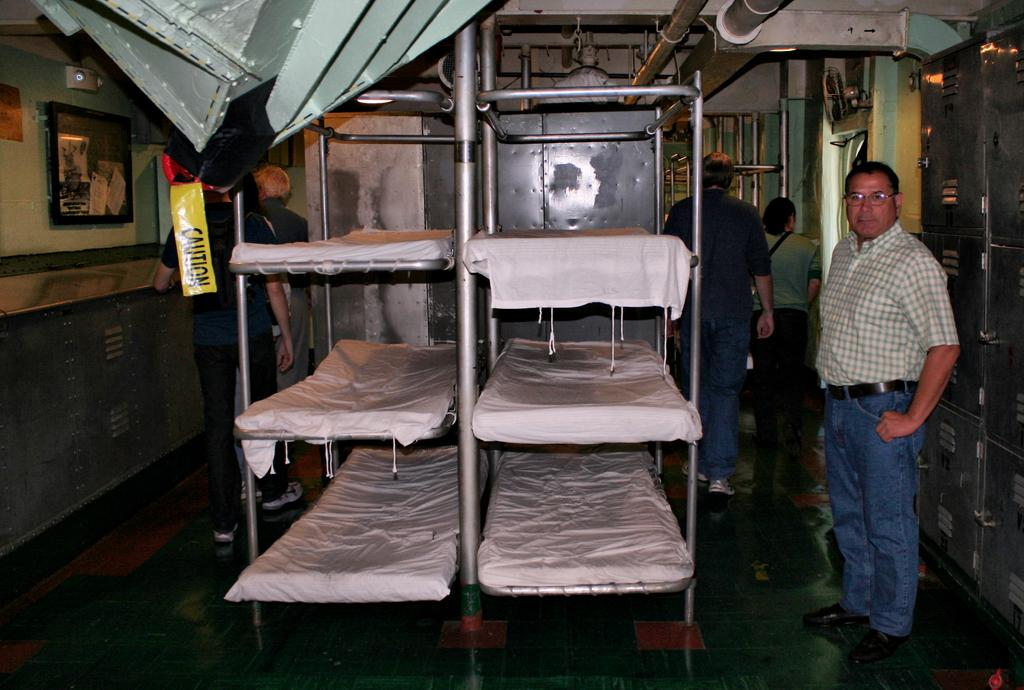Provide a one-sentence caption for the provided image. A man is standing by a row of bunk beds where a yellow sign is hanging that says Caution. 